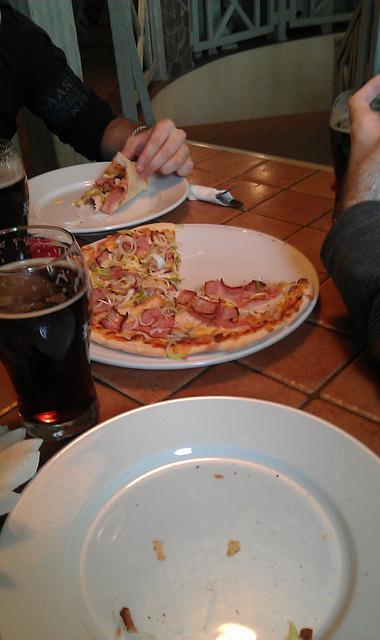How many glasses are on the table?
Keep it brief. 2. What are the people eating?
Concise answer only. Pizza. Do you see a glass of beer?
Concise answer only. Yes. Are the people having carbonated drinks with their meal?
Be succinct. Yes. What is the traditional name for the type of pizza in this picture?
Keep it brief. Thin crust. Is the drink in the cup soda?
Be succinct. Yes. Is this Chinese food?
Concise answer only. No. How many pizzas are there?
Answer briefly. 1. How many people are there?
Keep it brief. 2. 